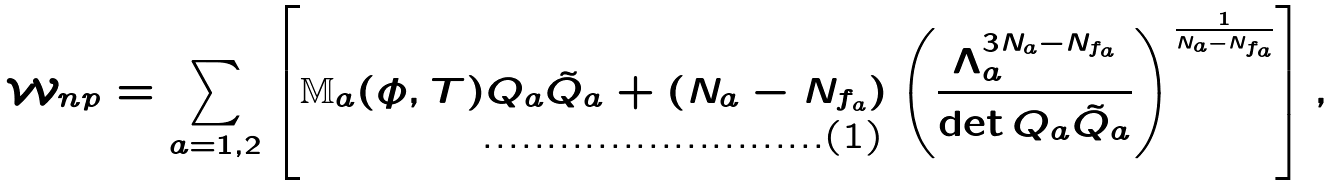Convert formula to latex. <formula><loc_0><loc_0><loc_500><loc_500>\mathcal { W } _ { n p } = \sum _ { a = 1 , 2 } \left [ \mathbb { M } _ { a } ( \phi , T ) Q _ { a } \tilde { Q } _ { a } + ( N _ { a } - N _ { f _ { a } } ) \left ( \frac { \Lambda _ { a } ^ { 3 N _ { a } - N _ { f _ { a } } } } { \det Q _ { a } \tilde { Q } _ { a } } \right ) ^ { \frac { 1 } { N _ { a } - N _ { f _ { a } } } } \right ] ,</formula> 